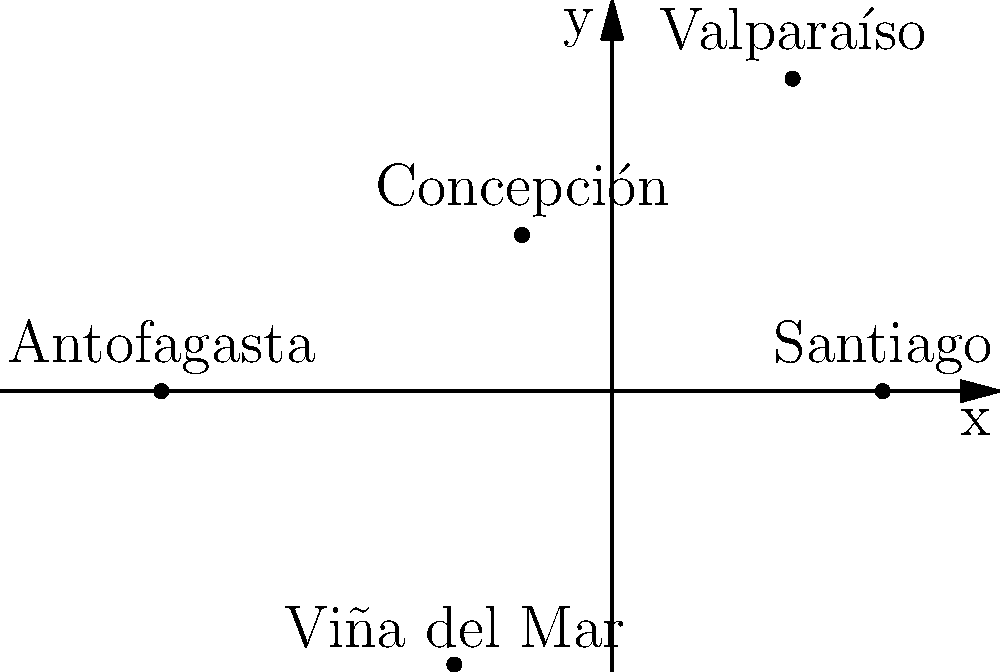In the polar coordinate plot of María Fernanda Zúñiga's tour locations in Chile, which city is represented by the point $(r, \theta) = (4, \frac{\pi}{3})$? To answer this question, we need to follow these steps:

1. Understand that in polar coordinates, a point is represented by its distance from the origin (r) and the angle it makes with the positive x-axis (θ).

2. Identify the point with coordinates $(r, \theta) = (4, \frac{\pi}{3})$ in the given plot.

3. The point we're looking for should be:
   - At a distance of 4 units from the origin
   - At an angle of $\frac{\pi}{3}$ radians (or 60 degrees) from the positive x-axis

4. Examine the plot and find the point that matches these criteria.

5. Read the label of the city associated with this point.

Looking at the plot, we can see that the point satisfying these conditions corresponds to the city of Valparaíso.
Answer: Valparaíso 